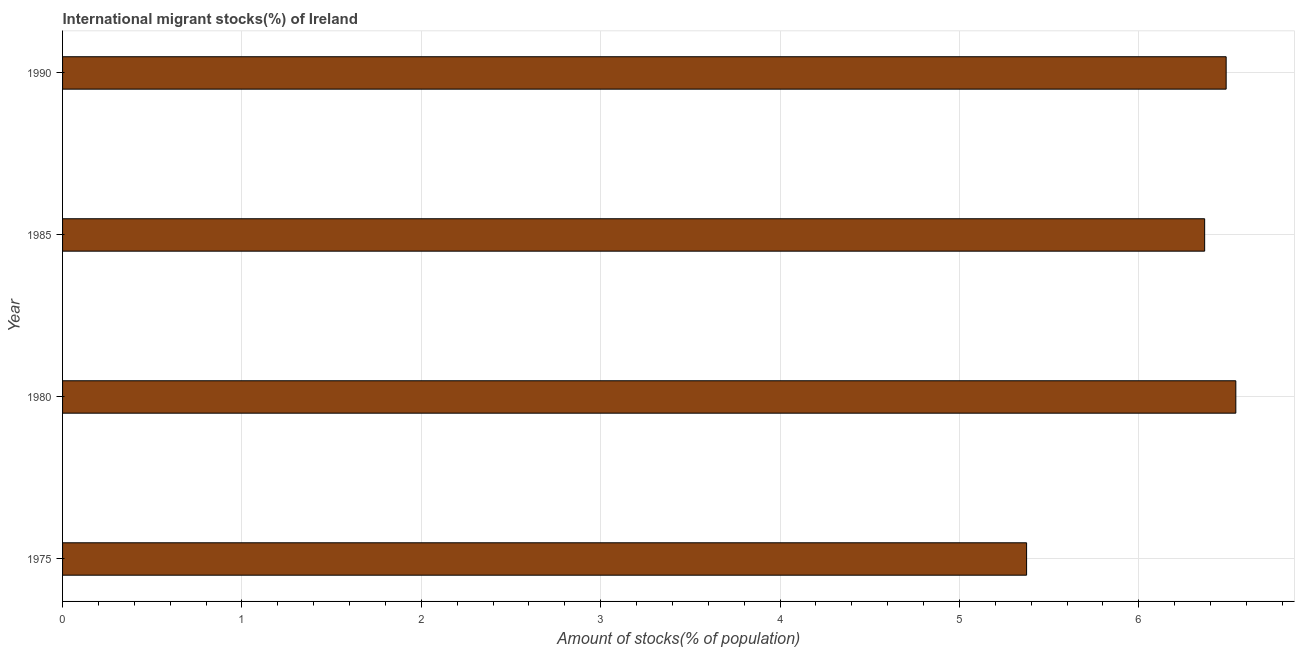What is the title of the graph?
Your response must be concise. International migrant stocks(%) of Ireland. What is the label or title of the X-axis?
Provide a short and direct response. Amount of stocks(% of population). What is the number of international migrant stocks in 1985?
Provide a short and direct response. 6.37. Across all years, what is the maximum number of international migrant stocks?
Make the answer very short. 6.54. Across all years, what is the minimum number of international migrant stocks?
Ensure brevity in your answer.  5.37. In which year was the number of international migrant stocks minimum?
Ensure brevity in your answer.  1975. What is the sum of the number of international migrant stocks?
Make the answer very short. 24.77. What is the difference between the number of international migrant stocks in 1980 and 1985?
Offer a terse response. 0.17. What is the average number of international migrant stocks per year?
Make the answer very short. 6.19. What is the median number of international migrant stocks?
Offer a very short reply. 6.43. In how many years, is the number of international migrant stocks greater than 3.4 %?
Make the answer very short. 4. What is the ratio of the number of international migrant stocks in 1975 to that in 1990?
Provide a succinct answer. 0.83. Is the number of international migrant stocks in 1985 less than that in 1990?
Give a very brief answer. Yes. What is the difference between the highest and the second highest number of international migrant stocks?
Give a very brief answer. 0.05. What is the difference between the highest and the lowest number of international migrant stocks?
Give a very brief answer. 1.17. In how many years, is the number of international migrant stocks greater than the average number of international migrant stocks taken over all years?
Give a very brief answer. 3. Are all the bars in the graph horizontal?
Your answer should be compact. Yes. Are the values on the major ticks of X-axis written in scientific E-notation?
Give a very brief answer. No. What is the Amount of stocks(% of population) in 1975?
Offer a very short reply. 5.37. What is the Amount of stocks(% of population) of 1980?
Give a very brief answer. 6.54. What is the Amount of stocks(% of population) in 1985?
Your response must be concise. 6.37. What is the Amount of stocks(% of population) of 1990?
Offer a very short reply. 6.49. What is the difference between the Amount of stocks(% of population) in 1975 and 1980?
Provide a succinct answer. -1.17. What is the difference between the Amount of stocks(% of population) in 1975 and 1985?
Your answer should be compact. -0.99. What is the difference between the Amount of stocks(% of population) in 1975 and 1990?
Your answer should be very brief. -1.11. What is the difference between the Amount of stocks(% of population) in 1980 and 1985?
Offer a very short reply. 0.17. What is the difference between the Amount of stocks(% of population) in 1980 and 1990?
Offer a terse response. 0.05. What is the difference between the Amount of stocks(% of population) in 1985 and 1990?
Make the answer very short. -0.12. What is the ratio of the Amount of stocks(% of population) in 1975 to that in 1980?
Your response must be concise. 0.82. What is the ratio of the Amount of stocks(% of population) in 1975 to that in 1985?
Your response must be concise. 0.84. What is the ratio of the Amount of stocks(% of population) in 1975 to that in 1990?
Provide a succinct answer. 0.83. What is the ratio of the Amount of stocks(% of population) in 1980 to that in 1985?
Keep it short and to the point. 1.03. What is the ratio of the Amount of stocks(% of population) in 1980 to that in 1990?
Your response must be concise. 1.01. 